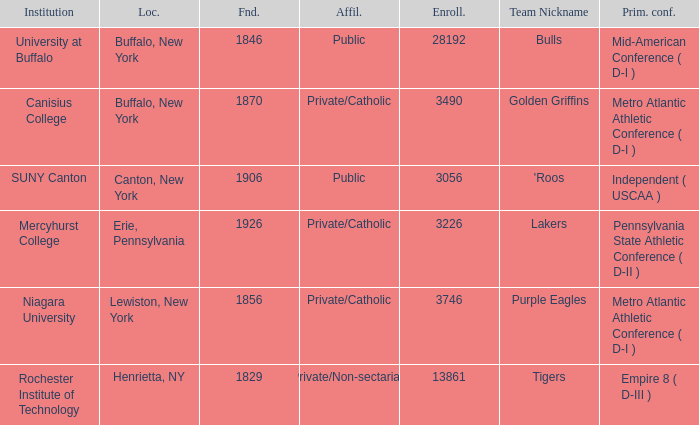What affiliation is Erie, Pennsylvania? Private/Catholic. 